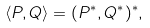Convert formula to latex. <formula><loc_0><loc_0><loc_500><loc_500>\langle P , Q \rangle = ( P ^ { * } , Q ^ { * } ) ^ { * } ,</formula> 